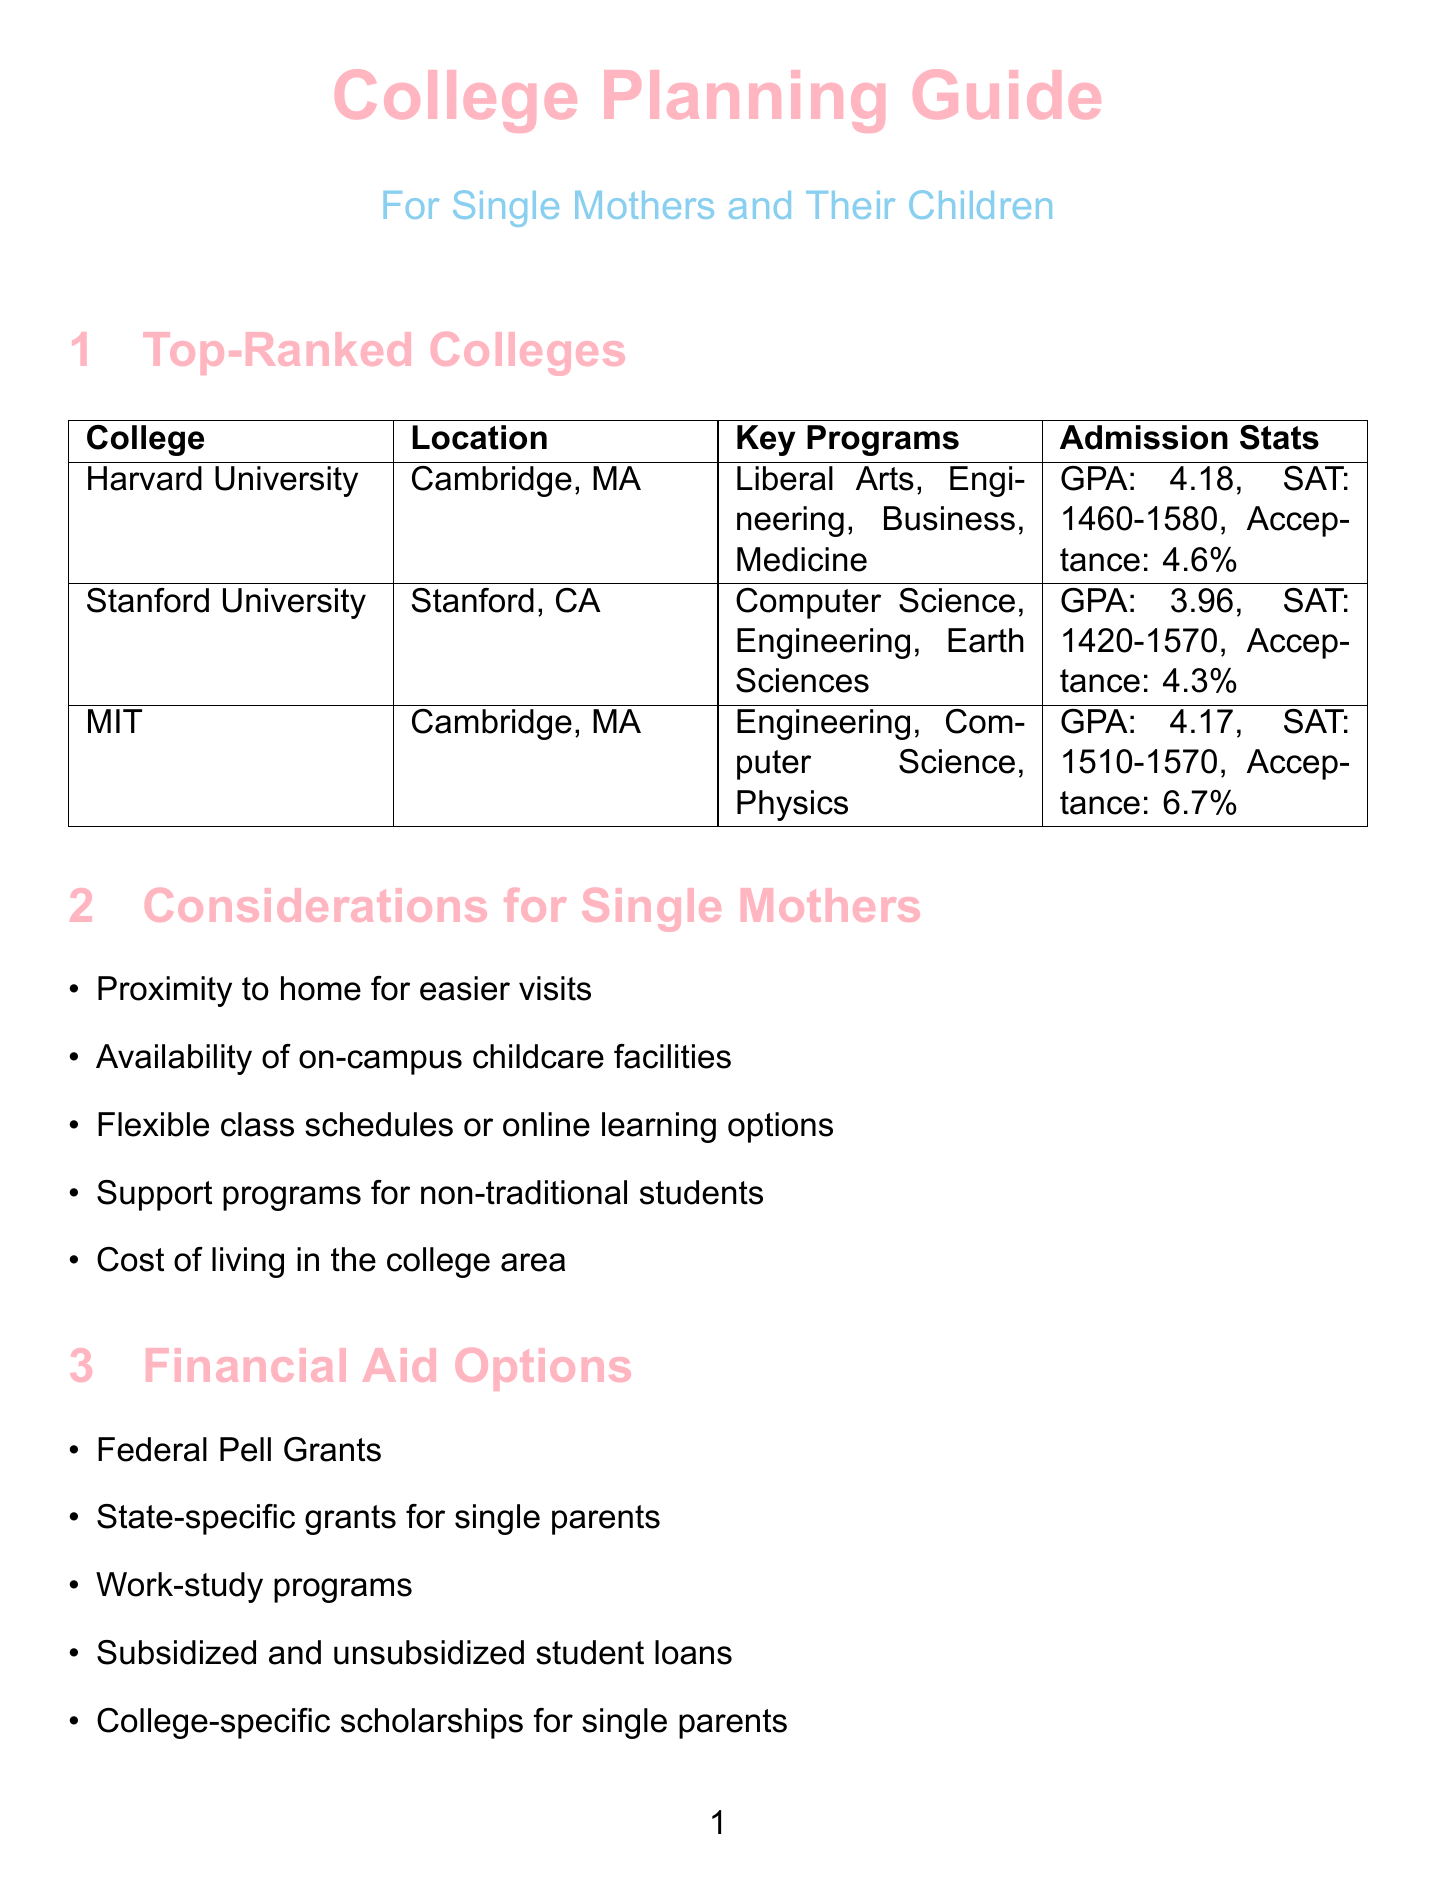What is the average GPA for admission to Harvard University? The average GPA for admission to Harvard University is listed in the document as 4.18.
Answer: 4.18 What are the key academic programs offered at Stanford University? The document specifies the key academic programs at Stanford University, which include Computer Science, Engineering, and Earth Sciences.
Answer: Computer Science, Engineering, Earth Sciences What is MIT's acceptance rate? The acceptance rate for MIT is provided as 6.7% in the document.
Answer: 6.7% What type of financial aid does Harvard University provide? According to the document, Harvard University offers need-blind admissions and meets 100% of demonstrated need as financial aid.
Answer: Need-blind admissions, meets 100% of demonstrated need Which degree has the highest median salary listed in the career outlook? The document indicates that the degree in Computer Science has the highest median salary at $88,240.
Answer: Computer Science What is one consideration for single mothers when choosing a college? The document includes various considerations for single mothers, one being the proximity to home for easier visits.
Answer: Proximity to home for easier visits What are two examples of financial aid options mentioned? The document lists multiple financial aid options, including Federal Pell Grants and state-specific grants for single parents.
Answer: Federal Pell Grants, state-specific grants for single parents How much faster is job growth in Computer Science compared to average? The document notes that job growth in Computer Science is 22%, which is categorized as much faster than average.
Answer: 22% (much faster than average) What is an important application tip mentioned in the document? The document advises starting the application process early as an important tip.
Answer: Start the application process early 